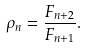<formula> <loc_0><loc_0><loc_500><loc_500>\rho _ { n } = \frac { F _ { n + 2 } } { F _ { n + 1 } } .</formula> 